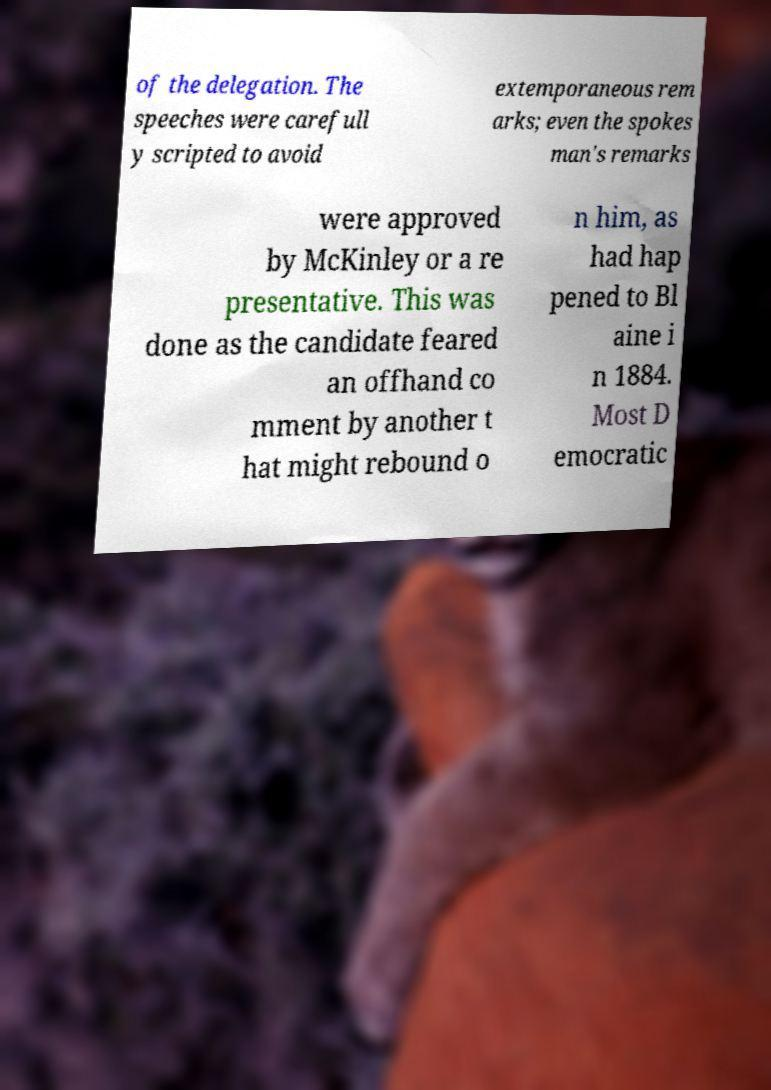Can you read and provide the text displayed in the image?This photo seems to have some interesting text. Can you extract and type it out for me? of the delegation. The speeches were carefull y scripted to avoid extemporaneous rem arks; even the spokes man's remarks were approved by McKinley or a re presentative. This was done as the candidate feared an offhand co mment by another t hat might rebound o n him, as had hap pened to Bl aine i n 1884. Most D emocratic 